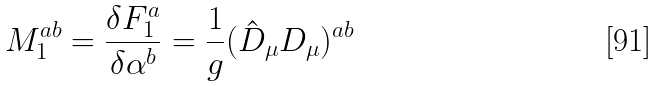Convert formula to latex. <formula><loc_0><loc_0><loc_500><loc_500>M _ { 1 } ^ { a b } = \frac { \delta F _ { 1 } ^ { a } } { \delta \alpha ^ { b } } = \frac { 1 } { g } ( \hat { D } _ { \mu } D _ { \mu } ) ^ { a b }</formula> 